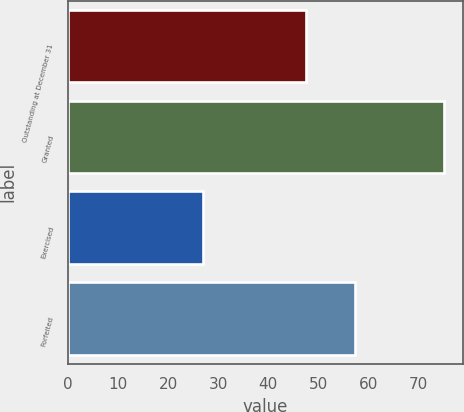Convert chart to OTSL. <chart><loc_0><loc_0><loc_500><loc_500><bar_chart><fcel>Outstanding at December 31<fcel>Granted<fcel>Exercised<fcel>Forfeited<nl><fcel>47.61<fcel>75.14<fcel>26.95<fcel>57.28<nl></chart> 